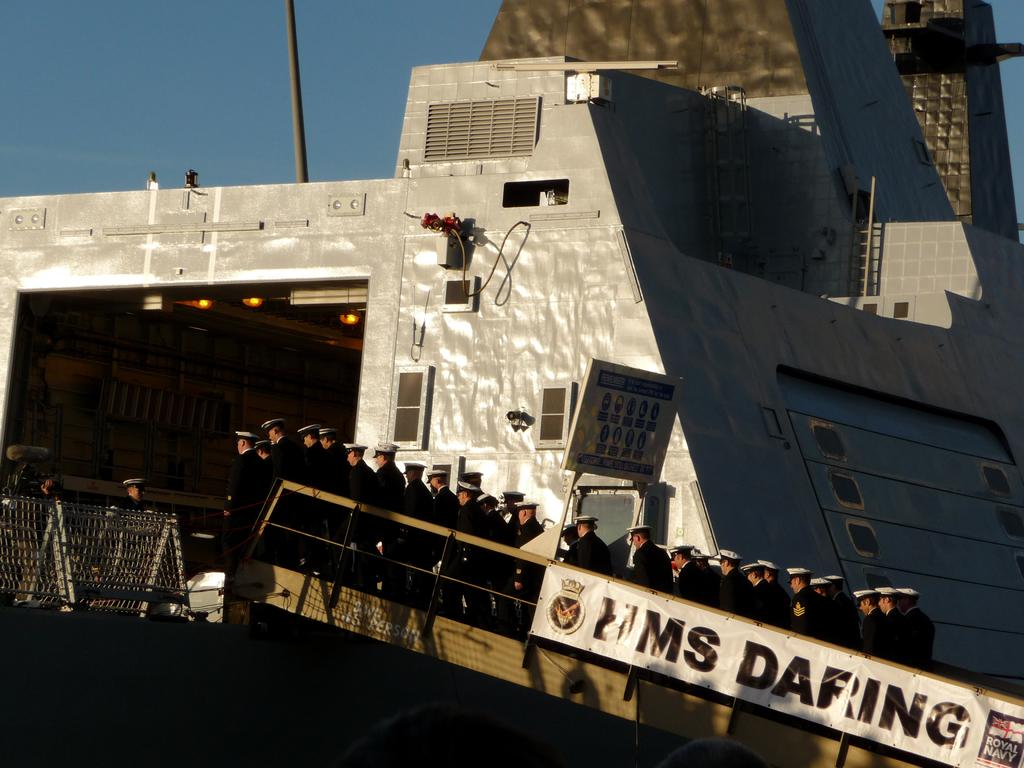What is the main subject of the image? The main subject of the image is a ship. What other elements are present in the image? There is a group of navy officers in the image. How are the navy officers positioned in the image? The navy officers are standing in a row. What colors are featured in the navy officers' uniforms? The navy officers are wearing black dress and white hats. What type of lettuce is being used for arithmetic calculations in the image? There is no lettuce or arithmetic calculations present in the image. How does the ship crush the navy officers in the image? The ship does not crush the navy officers in the image; they are standing in a row near the ship. 